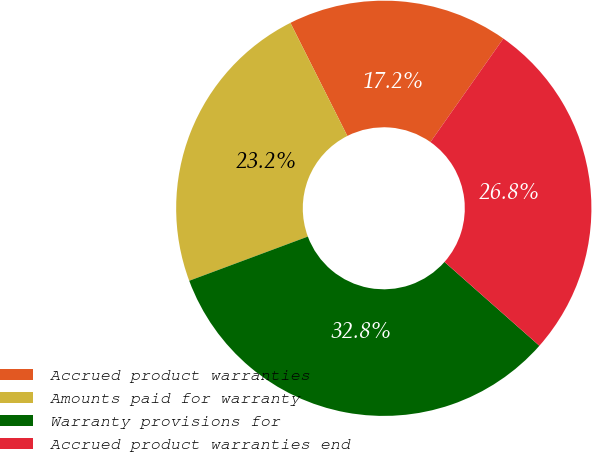Convert chart. <chart><loc_0><loc_0><loc_500><loc_500><pie_chart><fcel>Accrued product warranties<fcel>Amounts paid for warranty<fcel>Warranty provisions for<fcel>Accrued product warranties end<nl><fcel>17.19%<fcel>23.25%<fcel>32.81%<fcel>26.75%<nl></chart> 